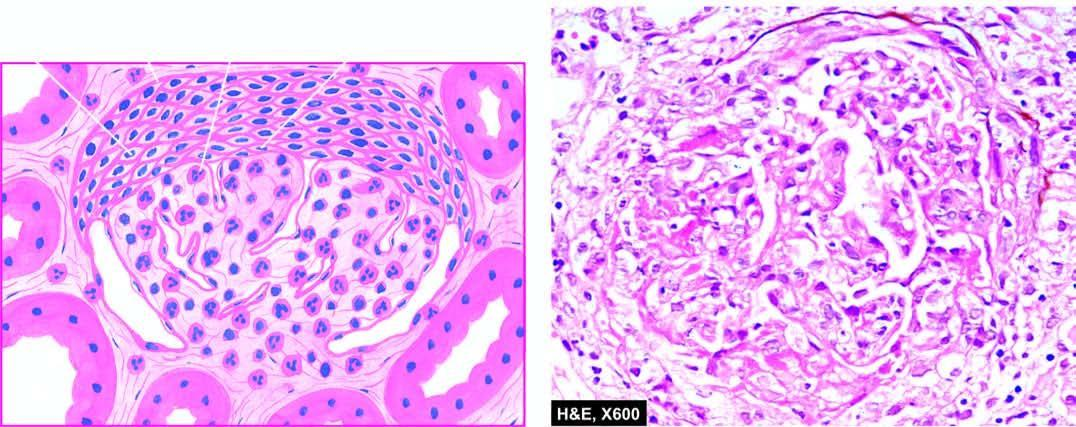what shows hypercellularity and leucocytic infiltration?
Answer the question using a single word or phrase. Tuft 